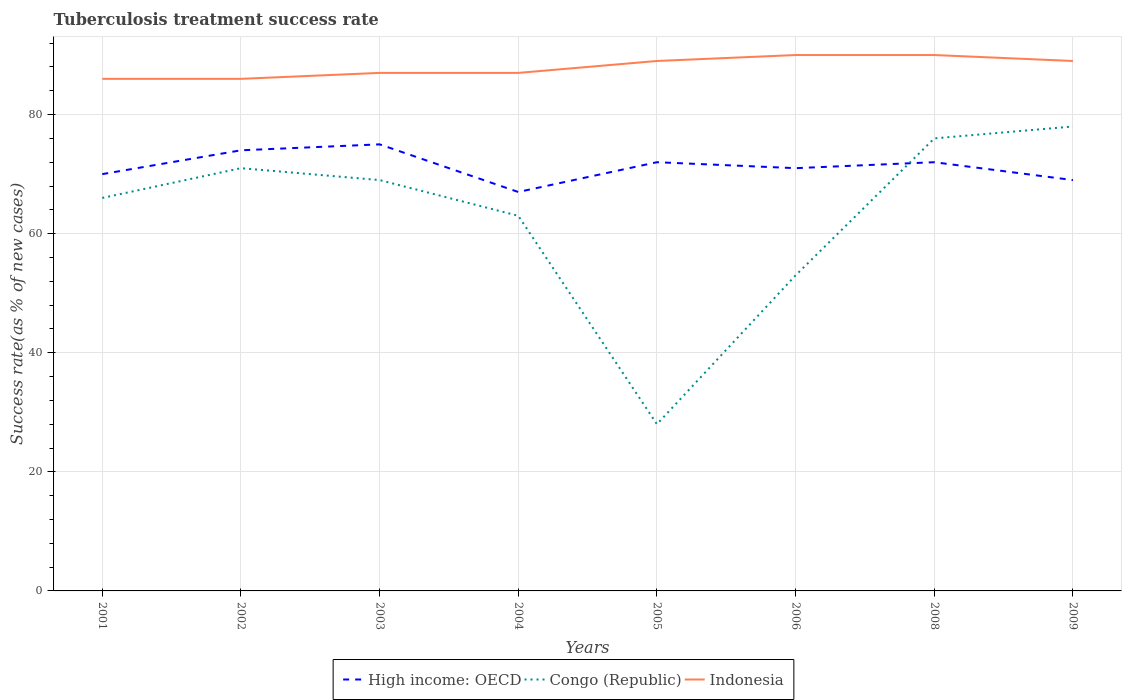Is the number of lines equal to the number of legend labels?
Keep it short and to the point. Yes. In which year was the tuberculosis treatment success rate in High income: OECD maximum?
Your answer should be very brief. 2004. What is the total tuberculosis treatment success rate in High income: OECD in the graph?
Your answer should be very brief. -1. What is the difference between the highest and the second highest tuberculosis treatment success rate in Congo (Republic)?
Provide a succinct answer. 50. What is the difference between the highest and the lowest tuberculosis treatment success rate in Congo (Republic)?
Make the answer very short. 5. Are the values on the major ticks of Y-axis written in scientific E-notation?
Your answer should be compact. No. What is the title of the graph?
Your answer should be compact. Tuberculosis treatment success rate. Does "Estonia" appear as one of the legend labels in the graph?
Make the answer very short. No. What is the label or title of the X-axis?
Give a very brief answer. Years. What is the label or title of the Y-axis?
Ensure brevity in your answer.  Success rate(as % of new cases). What is the Success rate(as % of new cases) in High income: OECD in 2001?
Make the answer very short. 70. What is the Success rate(as % of new cases) of Congo (Republic) in 2001?
Keep it short and to the point. 66. What is the Success rate(as % of new cases) of Indonesia in 2001?
Your answer should be compact. 86. What is the Success rate(as % of new cases) of Indonesia in 2002?
Provide a succinct answer. 86. What is the Success rate(as % of new cases) of Indonesia in 2004?
Provide a short and direct response. 87. What is the Success rate(as % of new cases) in High income: OECD in 2005?
Give a very brief answer. 72. What is the Success rate(as % of new cases) in Indonesia in 2005?
Your response must be concise. 89. What is the Success rate(as % of new cases) of Congo (Republic) in 2006?
Keep it short and to the point. 53. What is the Success rate(as % of new cases) in Indonesia in 2006?
Keep it short and to the point. 90. What is the Success rate(as % of new cases) in High income: OECD in 2009?
Keep it short and to the point. 69. What is the Success rate(as % of new cases) in Indonesia in 2009?
Your answer should be very brief. 89. Across all years, what is the maximum Success rate(as % of new cases) of High income: OECD?
Provide a short and direct response. 75. Across all years, what is the maximum Success rate(as % of new cases) of Indonesia?
Provide a short and direct response. 90. Across all years, what is the minimum Success rate(as % of new cases) in High income: OECD?
Your answer should be compact. 67. Across all years, what is the minimum Success rate(as % of new cases) in Congo (Republic)?
Your response must be concise. 28. Across all years, what is the minimum Success rate(as % of new cases) of Indonesia?
Give a very brief answer. 86. What is the total Success rate(as % of new cases) in High income: OECD in the graph?
Your answer should be compact. 570. What is the total Success rate(as % of new cases) of Congo (Republic) in the graph?
Offer a very short reply. 504. What is the total Success rate(as % of new cases) of Indonesia in the graph?
Offer a very short reply. 704. What is the difference between the Success rate(as % of new cases) in High income: OECD in 2001 and that in 2002?
Keep it short and to the point. -4. What is the difference between the Success rate(as % of new cases) in Indonesia in 2001 and that in 2002?
Your answer should be compact. 0. What is the difference between the Success rate(as % of new cases) of Congo (Republic) in 2001 and that in 2003?
Give a very brief answer. -3. What is the difference between the Success rate(as % of new cases) in High income: OECD in 2001 and that in 2004?
Your answer should be very brief. 3. What is the difference between the Success rate(as % of new cases) in Indonesia in 2001 and that in 2005?
Ensure brevity in your answer.  -3. What is the difference between the Success rate(as % of new cases) in Indonesia in 2001 and that in 2006?
Offer a very short reply. -4. What is the difference between the Success rate(as % of new cases) of High income: OECD in 2001 and that in 2008?
Give a very brief answer. -2. What is the difference between the Success rate(as % of new cases) of Indonesia in 2001 and that in 2008?
Make the answer very short. -4. What is the difference between the Success rate(as % of new cases) of Congo (Republic) in 2001 and that in 2009?
Your answer should be compact. -12. What is the difference between the Success rate(as % of new cases) of High income: OECD in 2002 and that in 2003?
Provide a short and direct response. -1. What is the difference between the Success rate(as % of new cases) in Indonesia in 2002 and that in 2003?
Make the answer very short. -1. What is the difference between the Success rate(as % of new cases) in High income: OECD in 2002 and that in 2004?
Your response must be concise. 7. What is the difference between the Success rate(as % of new cases) in Indonesia in 2002 and that in 2004?
Provide a short and direct response. -1. What is the difference between the Success rate(as % of new cases) of Congo (Republic) in 2002 and that in 2005?
Make the answer very short. 43. What is the difference between the Success rate(as % of new cases) in High income: OECD in 2002 and that in 2006?
Make the answer very short. 3. What is the difference between the Success rate(as % of new cases) in Indonesia in 2002 and that in 2006?
Provide a short and direct response. -4. What is the difference between the Success rate(as % of new cases) of High income: OECD in 2002 and that in 2008?
Keep it short and to the point. 2. What is the difference between the Success rate(as % of new cases) in Indonesia in 2002 and that in 2008?
Your response must be concise. -4. What is the difference between the Success rate(as % of new cases) of High income: OECD in 2002 and that in 2009?
Provide a short and direct response. 5. What is the difference between the Success rate(as % of new cases) of Congo (Republic) in 2002 and that in 2009?
Provide a succinct answer. -7. What is the difference between the Success rate(as % of new cases) of Congo (Republic) in 2003 and that in 2004?
Ensure brevity in your answer.  6. What is the difference between the Success rate(as % of new cases) of High income: OECD in 2003 and that in 2008?
Provide a succinct answer. 3. What is the difference between the Success rate(as % of new cases) in Congo (Republic) in 2003 and that in 2008?
Your answer should be very brief. -7. What is the difference between the Success rate(as % of new cases) of Indonesia in 2003 and that in 2008?
Provide a succinct answer. -3. What is the difference between the Success rate(as % of new cases) of High income: OECD in 2003 and that in 2009?
Your response must be concise. 6. What is the difference between the Success rate(as % of new cases) in Congo (Republic) in 2003 and that in 2009?
Your response must be concise. -9. What is the difference between the Success rate(as % of new cases) of Indonesia in 2003 and that in 2009?
Your response must be concise. -2. What is the difference between the Success rate(as % of new cases) of Congo (Republic) in 2004 and that in 2005?
Your response must be concise. 35. What is the difference between the Success rate(as % of new cases) in Indonesia in 2004 and that in 2006?
Ensure brevity in your answer.  -3. What is the difference between the Success rate(as % of new cases) in High income: OECD in 2004 and that in 2008?
Provide a short and direct response. -5. What is the difference between the Success rate(as % of new cases) in Congo (Republic) in 2004 and that in 2009?
Keep it short and to the point. -15. What is the difference between the Success rate(as % of new cases) of High income: OECD in 2005 and that in 2006?
Ensure brevity in your answer.  1. What is the difference between the Success rate(as % of new cases) of Congo (Republic) in 2005 and that in 2006?
Offer a terse response. -25. What is the difference between the Success rate(as % of new cases) in Indonesia in 2005 and that in 2006?
Offer a terse response. -1. What is the difference between the Success rate(as % of new cases) of High income: OECD in 2005 and that in 2008?
Provide a succinct answer. 0. What is the difference between the Success rate(as % of new cases) in Congo (Republic) in 2005 and that in 2008?
Provide a succinct answer. -48. What is the difference between the Success rate(as % of new cases) of High income: OECD in 2006 and that in 2008?
Give a very brief answer. -1. What is the difference between the Success rate(as % of new cases) of Congo (Republic) in 2006 and that in 2009?
Give a very brief answer. -25. What is the difference between the Success rate(as % of new cases) of High income: OECD in 2008 and that in 2009?
Make the answer very short. 3. What is the difference between the Success rate(as % of new cases) of Indonesia in 2008 and that in 2009?
Offer a very short reply. 1. What is the difference between the Success rate(as % of new cases) in Congo (Republic) in 2001 and the Success rate(as % of new cases) in Indonesia in 2002?
Keep it short and to the point. -20. What is the difference between the Success rate(as % of new cases) of Congo (Republic) in 2001 and the Success rate(as % of new cases) of Indonesia in 2003?
Offer a very short reply. -21. What is the difference between the Success rate(as % of new cases) of High income: OECD in 2001 and the Success rate(as % of new cases) of Congo (Republic) in 2004?
Your answer should be compact. 7. What is the difference between the Success rate(as % of new cases) of High income: OECD in 2001 and the Success rate(as % of new cases) of Indonesia in 2004?
Your response must be concise. -17. What is the difference between the Success rate(as % of new cases) of High income: OECD in 2001 and the Success rate(as % of new cases) of Indonesia in 2005?
Offer a very short reply. -19. What is the difference between the Success rate(as % of new cases) in Congo (Republic) in 2001 and the Success rate(as % of new cases) in Indonesia in 2006?
Your answer should be compact. -24. What is the difference between the Success rate(as % of new cases) of High income: OECD in 2001 and the Success rate(as % of new cases) of Congo (Republic) in 2008?
Offer a terse response. -6. What is the difference between the Success rate(as % of new cases) in High income: OECD in 2001 and the Success rate(as % of new cases) in Indonesia in 2008?
Provide a succinct answer. -20. What is the difference between the Success rate(as % of new cases) of High income: OECD in 2001 and the Success rate(as % of new cases) of Indonesia in 2009?
Offer a very short reply. -19. What is the difference between the Success rate(as % of new cases) of Congo (Republic) in 2001 and the Success rate(as % of new cases) of Indonesia in 2009?
Make the answer very short. -23. What is the difference between the Success rate(as % of new cases) in High income: OECD in 2002 and the Success rate(as % of new cases) in Congo (Republic) in 2003?
Give a very brief answer. 5. What is the difference between the Success rate(as % of new cases) of High income: OECD in 2002 and the Success rate(as % of new cases) of Indonesia in 2003?
Give a very brief answer. -13. What is the difference between the Success rate(as % of new cases) of Congo (Republic) in 2002 and the Success rate(as % of new cases) of Indonesia in 2003?
Make the answer very short. -16. What is the difference between the Success rate(as % of new cases) in Congo (Republic) in 2002 and the Success rate(as % of new cases) in Indonesia in 2004?
Your response must be concise. -16. What is the difference between the Success rate(as % of new cases) of High income: OECD in 2002 and the Success rate(as % of new cases) of Congo (Republic) in 2005?
Provide a succinct answer. 46. What is the difference between the Success rate(as % of new cases) in Congo (Republic) in 2002 and the Success rate(as % of new cases) in Indonesia in 2005?
Keep it short and to the point. -18. What is the difference between the Success rate(as % of new cases) in High income: OECD in 2002 and the Success rate(as % of new cases) in Congo (Republic) in 2006?
Offer a terse response. 21. What is the difference between the Success rate(as % of new cases) of Congo (Republic) in 2002 and the Success rate(as % of new cases) of Indonesia in 2006?
Provide a short and direct response. -19. What is the difference between the Success rate(as % of new cases) in High income: OECD in 2002 and the Success rate(as % of new cases) in Congo (Republic) in 2008?
Make the answer very short. -2. What is the difference between the Success rate(as % of new cases) in High income: OECD in 2002 and the Success rate(as % of new cases) in Congo (Republic) in 2009?
Offer a very short reply. -4. What is the difference between the Success rate(as % of new cases) of Congo (Republic) in 2002 and the Success rate(as % of new cases) of Indonesia in 2009?
Offer a terse response. -18. What is the difference between the Success rate(as % of new cases) in Congo (Republic) in 2003 and the Success rate(as % of new cases) in Indonesia in 2004?
Your answer should be compact. -18. What is the difference between the Success rate(as % of new cases) in High income: OECD in 2003 and the Success rate(as % of new cases) in Indonesia in 2006?
Provide a short and direct response. -15. What is the difference between the Success rate(as % of new cases) of Congo (Republic) in 2003 and the Success rate(as % of new cases) of Indonesia in 2006?
Your answer should be very brief. -21. What is the difference between the Success rate(as % of new cases) in High income: OECD in 2003 and the Success rate(as % of new cases) in Congo (Republic) in 2008?
Offer a very short reply. -1. What is the difference between the Success rate(as % of new cases) in Congo (Republic) in 2003 and the Success rate(as % of new cases) in Indonesia in 2008?
Offer a terse response. -21. What is the difference between the Success rate(as % of new cases) in High income: OECD in 2003 and the Success rate(as % of new cases) in Indonesia in 2009?
Provide a succinct answer. -14. What is the difference between the Success rate(as % of new cases) of Congo (Republic) in 2003 and the Success rate(as % of new cases) of Indonesia in 2009?
Ensure brevity in your answer.  -20. What is the difference between the Success rate(as % of new cases) of High income: OECD in 2004 and the Success rate(as % of new cases) of Congo (Republic) in 2005?
Your answer should be very brief. 39. What is the difference between the Success rate(as % of new cases) of High income: OECD in 2004 and the Success rate(as % of new cases) of Indonesia in 2005?
Offer a terse response. -22. What is the difference between the Success rate(as % of new cases) in High income: OECD in 2004 and the Success rate(as % of new cases) in Indonesia in 2006?
Your response must be concise. -23. What is the difference between the Success rate(as % of new cases) of High income: OECD in 2004 and the Success rate(as % of new cases) of Indonesia in 2008?
Give a very brief answer. -23. What is the difference between the Success rate(as % of new cases) in High income: OECD in 2004 and the Success rate(as % of new cases) in Indonesia in 2009?
Your response must be concise. -22. What is the difference between the Success rate(as % of new cases) in Congo (Republic) in 2004 and the Success rate(as % of new cases) in Indonesia in 2009?
Your answer should be very brief. -26. What is the difference between the Success rate(as % of new cases) in High income: OECD in 2005 and the Success rate(as % of new cases) in Congo (Republic) in 2006?
Ensure brevity in your answer.  19. What is the difference between the Success rate(as % of new cases) in Congo (Republic) in 2005 and the Success rate(as % of new cases) in Indonesia in 2006?
Ensure brevity in your answer.  -62. What is the difference between the Success rate(as % of new cases) of High income: OECD in 2005 and the Success rate(as % of new cases) of Indonesia in 2008?
Your answer should be compact. -18. What is the difference between the Success rate(as % of new cases) in Congo (Republic) in 2005 and the Success rate(as % of new cases) in Indonesia in 2008?
Keep it short and to the point. -62. What is the difference between the Success rate(as % of new cases) of High income: OECD in 2005 and the Success rate(as % of new cases) of Indonesia in 2009?
Give a very brief answer. -17. What is the difference between the Success rate(as % of new cases) in Congo (Republic) in 2005 and the Success rate(as % of new cases) in Indonesia in 2009?
Make the answer very short. -61. What is the difference between the Success rate(as % of new cases) in High income: OECD in 2006 and the Success rate(as % of new cases) in Congo (Republic) in 2008?
Keep it short and to the point. -5. What is the difference between the Success rate(as % of new cases) of High income: OECD in 2006 and the Success rate(as % of new cases) of Indonesia in 2008?
Your response must be concise. -19. What is the difference between the Success rate(as % of new cases) in Congo (Republic) in 2006 and the Success rate(as % of new cases) in Indonesia in 2008?
Keep it short and to the point. -37. What is the difference between the Success rate(as % of new cases) in High income: OECD in 2006 and the Success rate(as % of new cases) in Congo (Republic) in 2009?
Your answer should be very brief. -7. What is the difference between the Success rate(as % of new cases) in Congo (Republic) in 2006 and the Success rate(as % of new cases) in Indonesia in 2009?
Provide a succinct answer. -36. What is the difference between the Success rate(as % of new cases) of High income: OECD in 2008 and the Success rate(as % of new cases) of Congo (Republic) in 2009?
Ensure brevity in your answer.  -6. What is the difference between the Success rate(as % of new cases) in Congo (Republic) in 2008 and the Success rate(as % of new cases) in Indonesia in 2009?
Your answer should be compact. -13. What is the average Success rate(as % of new cases) in High income: OECD per year?
Make the answer very short. 71.25. What is the average Success rate(as % of new cases) in Indonesia per year?
Provide a succinct answer. 88. In the year 2001, what is the difference between the Success rate(as % of new cases) of High income: OECD and Success rate(as % of new cases) of Congo (Republic)?
Your response must be concise. 4. In the year 2001, what is the difference between the Success rate(as % of new cases) of Congo (Republic) and Success rate(as % of new cases) of Indonesia?
Your answer should be very brief. -20. In the year 2002, what is the difference between the Success rate(as % of new cases) of High income: OECD and Success rate(as % of new cases) of Indonesia?
Provide a short and direct response. -12. In the year 2002, what is the difference between the Success rate(as % of new cases) of Congo (Republic) and Success rate(as % of new cases) of Indonesia?
Provide a succinct answer. -15. In the year 2003, what is the difference between the Success rate(as % of new cases) in High income: OECD and Success rate(as % of new cases) in Congo (Republic)?
Your answer should be compact. 6. In the year 2003, what is the difference between the Success rate(as % of new cases) in High income: OECD and Success rate(as % of new cases) in Indonesia?
Make the answer very short. -12. In the year 2003, what is the difference between the Success rate(as % of new cases) in Congo (Republic) and Success rate(as % of new cases) in Indonesia?
Your response must be concise. -18. In the year 2004, what is the difference between the Success rate(as % of new cases) of High income: OECD and Success rate(as % of new cases) of Indonesia?
Ensure brevity in your answer.  -20. In the year 2004, what is the difference between the Success rate(as % of new cases) in Congo (Republic) and Success rate(as % of new cases) in Indonesia?
Keep it short and to the point. -24. In the year 2005, what is the difference between the Success rate(as % of new cases) in High income: OECD and Success rate(as % of new cases) in Indonesia?
Your response must be concise. -17. In the year 2005, what is the difference between the Success rate(as % of new cases) in Congo (Republic) and Success rate(as % of new cases) in Indonesia?
Your answer should be compact. -61. In the year 2006, what is the difference between the Success rate(as % of new cases) in Congo (Republic) and Success rate(as % of new cases) in Indonesia?
Keep it short and to the point. -37. In the year 2008, what is the difference between the Success rate(as % of new cases) of Congo (Republic) and Success rate(as % of new cases) of Indonesia?
Make the answer very short. -14. In the year 2009, what is the difference between the Success rate(as % of new cases) of High income: OECD and Success rate(as % of new cases) of Indonesia?
Give a very brief answer. -20. In the year 2009, what is the difference between the Success rate(as % of new cases) in Congo (Republic) and Success rate(as % of new cases) in Indonesia?
Your response must be concise. -11. What is the ratio of the Success rate(as % of new cases) in High income: OECD in 2001 to that in 2002?
Ensure brevity in your answer.  0.95. What is the ratio of the Success rate(as % of new cases) of Congo (Republic) in 2001 to that in 2002?
Keep it short and to the point. 0.93. What is the ratio of the Success rate(as % of new cases) in High income: OECD in 2001 to that in 2003?
Your response must be concise. 0.93. What is the ratio of the Success rate(as % of new cases) of Congo (Republic) in 2001 to that in 2003?
Your answer should be compact. 0.96. What is the ratio of the Success rate(as % of new cases) in Indonesia in 2001 to that in 2003?
Your answer should be compact. 0.99. What is the ratio of the Success rate(as % of new cases) in High income: OECD in 2001 to that in 2004?
Provide a short and direct response. 1.04. What is the ratio of the Success rate(as % of new cases) in Congo (Republic) in 2001 to that in 2004?
Make the answer very short. 1.05. What is the ratio of the Success rate(as % of new cases) in Indonesia in 2001 to that in 2004?
Offer a terse response. 0.99. What is the ratio of the Success rate(as % of new cases) of High income: OECD in 2001 to that in 2005?
Give a very brief answer. 0.97. What is the ratio of the Success rate(as % of new cases) in Congo (Republic) in 2001 to that in 2005?
Offer a very short reply. 2.36. What is the ratio of the Success rate(as % of new cases) in Indonesia in 2001 to that in 2005?
Your answer should be very brief. 0.97. What is the ratio of the Success rate(as % of new cases) in High income: OECD in 2001 to that in 2006?
Provide a succinct answer. 0.99. What is the ratio of the Success rate(as % of new cases) of Congo (Republic) in 2001 to that in 2006?
Keep it short and to the point. 1.25. What is the ratio of the Success rate(as % of new cases) of Indonesia in 2001 to that in 2006?
Keep it short and to the point. 0.96. What is the ratio of the Success rate(as % of new cases) in High income: OECD in 2001 to that in 2008?
Give a very brief answer. 0.97. What is the ratio of the Success rate(as % of new cases) in Congo (Republic) in 2001 to that in 2008?
Ensure brevity in your answer.  0.87. What is the ratio of the Success rate(as % of new cases) in Indonesia in 2001 to that in 2008?
Offer a terse response. 0.96. What is the ratio of the Success rate(as % of new cases) of High income: OECD in 2001 to that in 2009?
Offer a terse response. 1.01. What is the ratio of the Success rate(as % of new cases) in Congo (Republic) in 2001 to that in 2009?
Offer a terse response. 0.85. What is the ratio of the Success rate(as % of new cases) in Indonesia in 2001 to that in 2009?
Give a very brief answer. 0.97. What is the ratio of the Success rate(as % of new cases) of High income: OECD in 2002 to that in 2003?
Offer a very short reply. 0.99. What is the ratio of the Success rate(as % of new cases) of Congo (Republic) in 2002 to that in 2003?
Your answer should be very brief. 1.03. What is the ratio of the Success rate(as % of new cases) of High income: OECD in 2002 to that in 2004?
Your answer should be very brief. 1.1. What is the ratio of the Success rate(as % of new cases) in Congo (Republic) in 2002 to that in 2004?
Offer a very short reply. 1.13. What is the ratio of the Success rate(as % of new cases) in Indonesia in 2002 to that in 2004?
Make the answer very short. 0.99. What is the ratio of the Success rate(as % of new cases) in High income: OECD in 2002 to that in 2005?
Your response must be concise. 1.03. What is the ratio of the Success rate(as % of new cases) in Congo (Republic) in 2002 to that in 2005?
Your answer should be very brief. 2.54. What is the ratio of the Success rate(as % of new cases) of Indonesia in 2002 to that in 2005?
Keep it short and to the point. 0.97. What is the ratio of the Success rate(as % of new cases) in High income: OECD in 2002 to that in 2006?
Make the answer very short. 1.04. What is the ratio of the Success rate(as % of new cases) of Congo (Republic) in 2002 to that in 2006?
Your response must be concise. 1.34. What is the ratio of the Success rate(as % of new cases) in Indonesia in 2002 to that in 2006?
Provide a short and direct response. 0.96. What is the ratio of the Success rate(as % of new cases) of High income: OECD in 2002 to that in 2008?
Your answer should be very brief. 1.03. What is the ratio of the Success rate(as % of new cases) in Congo (Republic) in 2002 to that in 2008?
Give a very brief answer. 0.93. What is the ratio of the Success rate(as % of new cases) in Indonesia in 2002 to that in 2008?
Provide a short and direct response. 0.96. What is the ratio of the Success rate(as % of new cases) of High income: OECD in 2002 to that in 2009?
Ensure brevity in your answer.  1.07. What is the ratio of the Success rate(as % of new cases) of Congo (Republic) in 2002 to that in 2009?
Offer a very short reply. 0.91. What is the ratio of the Success rate(as % of new cases) of Indonesia in 2002 to that in 2009?
Provide a short and direct response. 0.97. What is the ratio of the Success rate(as % of new cases) in High income: OECD in 2003 to that in 2004?
Offer a very short reply. 1.12. What is the ratio of the Success rate(as % of new cases) of Congo (Republic) in 2003 to that in 2004?
Ensure brevity in your answer.  1.1. What is the ratio of the Success rate(as % of new cases) of High income: OECD in 2003 to that in 2005?
Ensure brevity in your answer.  1.04. What is the ratio of the Success rate(as % of new cases) in Congo (Republic) in 2003 to that in 2005?
Keep it short and to the point. 2.46. What is the ratio of the Success rate(as % of new cases) of Indonesia in 2003 to that in 2005?
Offer a very short reply. 0.98. What is the ratio of the Success rate(as % of new cases) of High income: OECD in 2003 to that in 2006?
Your answer should be very brief. 1.06. What is the ratio of the Success rate(as % of new cases) of Congo (Republic) in 2003 to that in 2006?
Offer a terse response. 1.3. What is the ratio of the Success rate(as % of new cases) in Indonesia in 2003 to that in 2006?
Provide a short and direct response. 0.97. What is the ratio of the Success rate(as % of new cases) of High income: OECD in 2003 to that in 2008?
Offer a very short reply. 1.04. What is the ratio of the Success rate(as % of new cases) of Congo (Republic) in 2003 to that in 2008?
Ensure brevity in your answer.  0.91. What is the ratio of the Success rate(as % of new cases) of Indonesia in 2003 to that in 2008?
Provide a short and direct response. 0.97. What is the ratio of the Success rate(as % of new cases) of High income: OECD in 2003 to that in 2009?
Provide a short and direct response. 1.09. What is the ratio of the Success rate(as % of new cases) in Congo (Republic) in 2003 to that in 2009?
Give a very brief answer. 0.88. What is the ratio of the Success rate(as % of new cases) in Indonesia in 2003 to that in 2009?
Your response must be concise. 0.98. What is the ratio of the Success rate(as % of new cases) in High income: OECD in 2004 to that in 2005?
Provide a short and direct response. 0.93. What is the ratio of the Success rate(as % of new cases) in Congo (Republic) in 2004 to that in 2005?
Your answer should be compact. 2.25. What is the ratio of the Success rate(as % of new cases) of Indonesia in 2004 to that in 2005?
Keep it short and to the point. 0.98. What is the ratio of the Success rate(as % of new cases) in High income: OECD in 2004 to that in 2006?
Give a very brief answer. 0.94. What is the ratio of the Success rate(as % of new cases) of Congo (Republic) in 2004 to that in 2006?
Your answer should be very brief. 1.19. What is the ratio of the Success rate(as % of new cases) of Indonesia in 2004 to that in 2006?
Make the answer very short. 0.97. What is the ratio of the Success rate(as % of new cases) in High income: OECD in 2004 to that in 2008?
Make the answer very short. 0.93. What is the ratio of the Success rate(as % of new cases) in Congo (Republic) in 2004 to that in 2008?
Your response must be concise. 0.83. What is the ratio of the Success rate(as % of new cases) in Indonesia in 2004 to that in 2008?
Your response must be concise. 0.97. What is the ratio of the Success rate(as % of new cases) in High income: OECD in 2004 to that in 2009?
Provide a succinct answer. 0.97. What is the ratio of the Success rate(as % of new cases) of Congo (Republic) in 2004 to that in 2009?
Your answer should be very brief. 0.81. What is the ratio of the Success rate(as % of new cases) of Indonesia in 2004 to that in 2009?
Offer a terse response. 0.98. What is the ratio of the Success rate(as % of new cases) of High income: OECD in 2005 to that in 2006?
Ensure brevity in your answer.  1.01. What is the ratio of the Success rate(as % of new cases) of Congo (Republic) in 2005 to that in 2006?
Your answer should be very brief. 0.53. What is the ratio of the Success rate(as % of new cases) of Indonesia in 2005 to that in 2006?
Provide a succinct answer. 0.99. What is the ratio of the Success rate(as % of new cases) in High income: OECD in 2005 to that in 2008?
Provide a short and direct response. 1. What is the ratio of the Success rate(as % of new cases) in Congo (Republic) in 2005 to that in 2008?
Keep it short and to the point. 0.37. What is the ratio of the Success rate(as % of new cases) in Indonesia in 2005 to that in 2008?
Provide a short and direct response. 0.99. What is the ratio of the Success rate(as % of new cases) of High income: OECD in 2005 to that in 2009?
Your answer should be very brief. 1.04. What is the ratio of the Success rate(as % of new cases) in Congo (Republic) in 2005 to that in 2009?
Ensure brevity in your answer.  0.36. What is the ratio of the Success rate(as % of new cases) of Indonesia in 2005 to that in 2009?
Ensure brevity in your answer.  1. What is the ratio of the Success rate(as % of new cases) in High income: OECD in 2006 to that in 2008?
Offer a very short reply. 0.99. What is the ratio of the Success rate(as % of new cases) of Congo (Republic) in 2006 to that in 2008?
Your answer should be very brief. 0.7. What is the ratio of the Success rate(as % of new cases) of Indonesia in 2006 to that in 2008?
Your answer should be very brief. 1. What is the ratio of the Success rate(as % of new cases) in High income: OECD in 2006 to that in 2009?
Your answer should be compact. 1.03. What is the ratio of the Success rate(as % of new cases) in Congo (Republic) in 2006 to that in 2009?
Offer a terse response. 0.68. What is the ratio of the Success rate(as % of new cases) in Indonesia in 2006 to that in 2009?
Keep it short and to the point. 1.01. What is the ratio of the Success rate(as % of new cases) in High income: OECD in 2008 to that in 2009?
Provide a succinct answer. 1.04. What is the ratio of the Success rate(as % of new cases) in Congo (Republic) in 2008 to that in 2009?
Keep it short and to the point. 0.97. What is the ratio of the Success rate(as % of new cases) of Indonesia in 2008 to that in 2009?
Provide a succinct answer. 1.01. What is the difference between the highest and the second highest Success rate(as % of new cases) of High income: OECD?
Provide a short and direct response. 1. What is the difference between the highest and the lowest Success rate(as % of new cases) in High income: OECD?
Your answer should be compact. 8. 